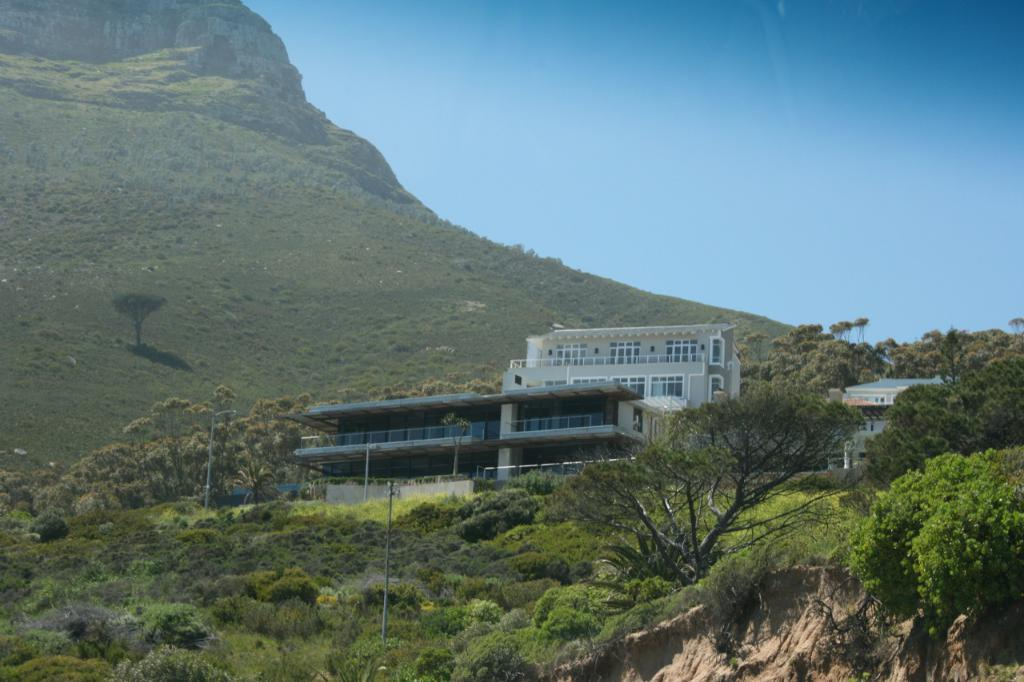What type of structures can be seen in the image? There are buildings in the image. What natural elements are present in the image? There are trees and mountains in the image. What man-made objects can be seen in the image? There are poles in the image. What part of the natural environment is visible in the image? The sky is visible in the image. How many times does the mom sneeze in the image? There is no mention of a mom or sneezing in the image, so this question cannot be answered. 